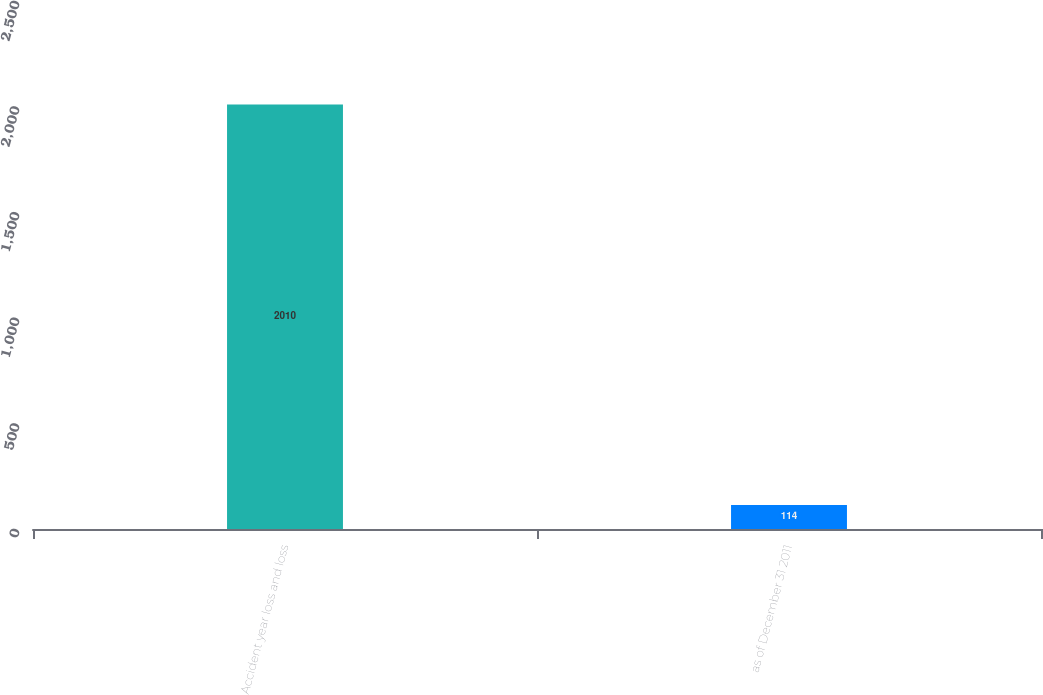<chart> <loc_0><loc_0><loc_500><loc_500><bar_chart><fcel>Accident year loss and loss<fcel>as of December 31 2011<nl><fcel>2010<fcel>114<nl></chart> 